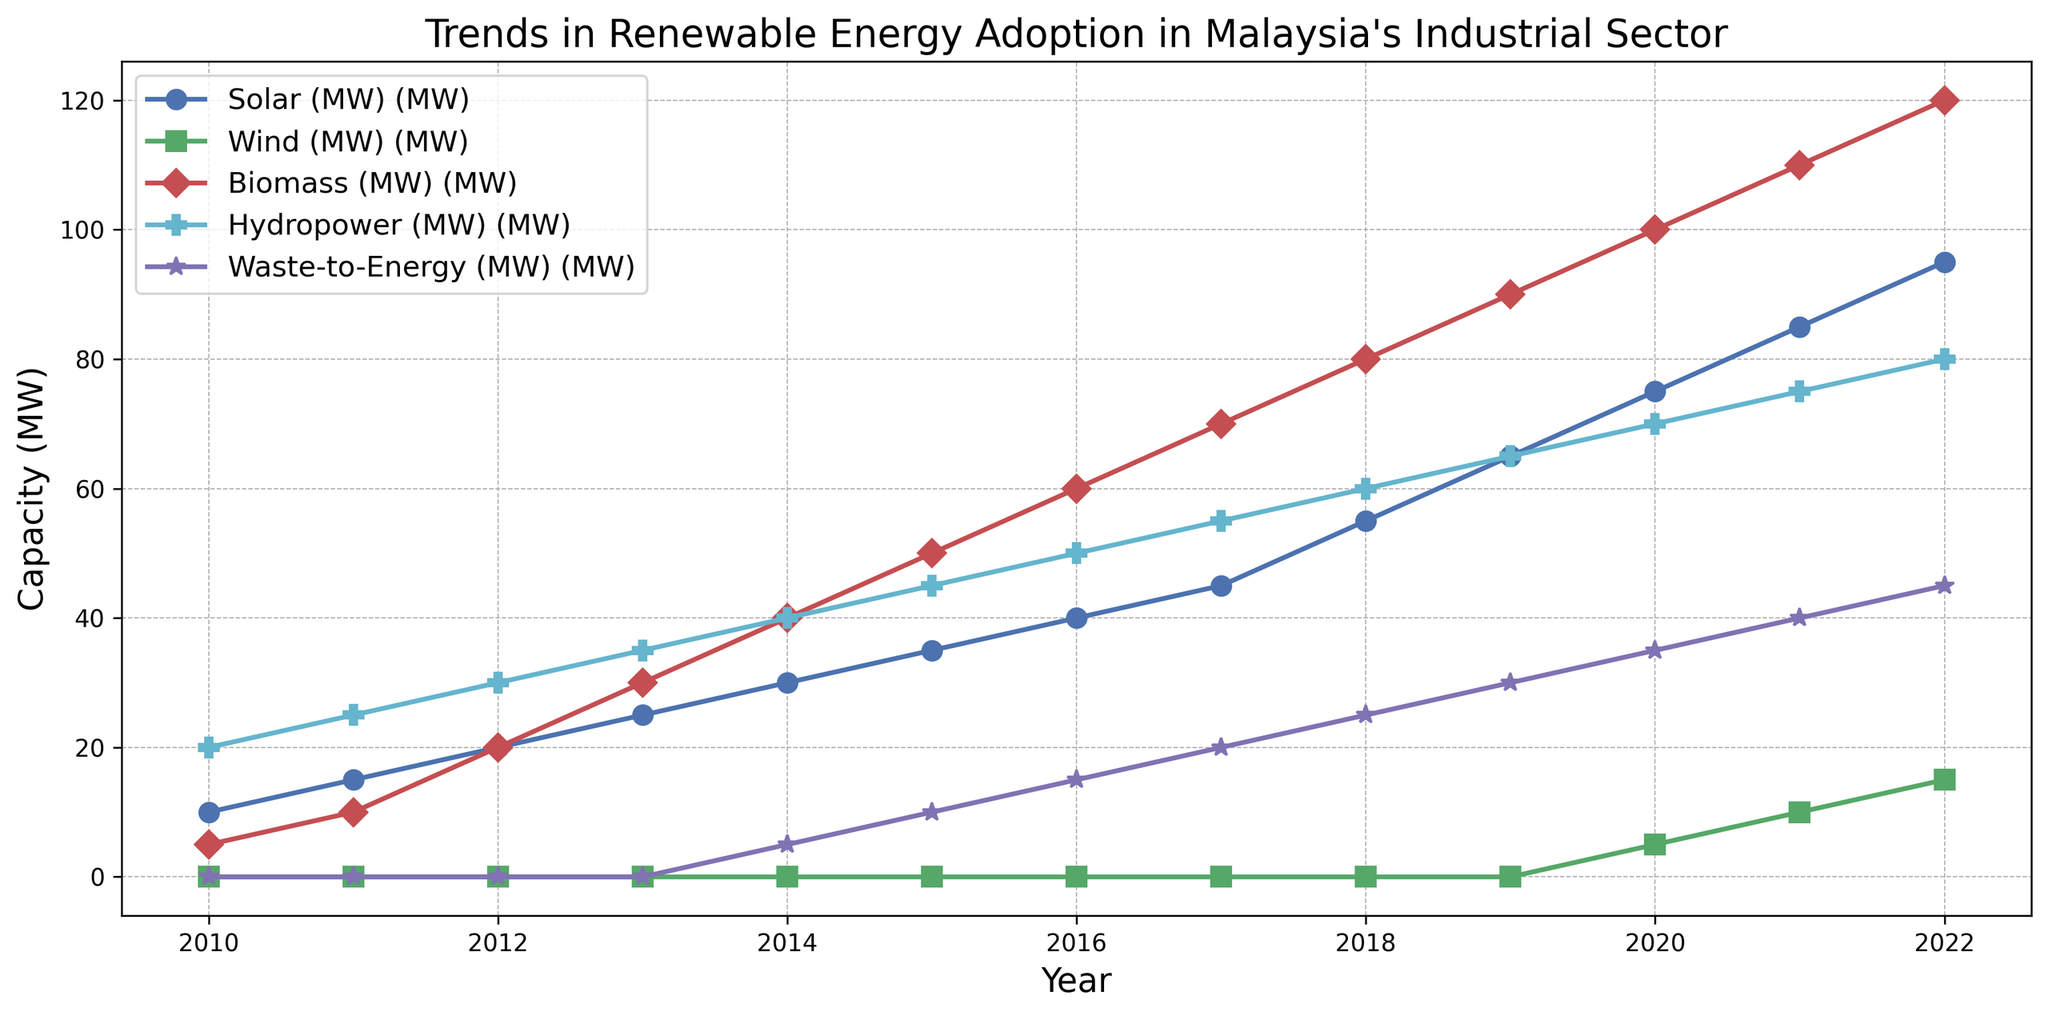What is the trend for Solar energy adoption from 2010 to 2022? To identify the trend, observe the line representing Solar (MW) from 2010 to 2022. It starts at 10 MW in 2010 and increases steadily to 95 MW by 2022.
Answer: Steady increase In which year did Wind energy first appear in the dataset, and what was its capacity? Look for the first non-zero value in the Wind (MW) line. Wind energy first appears in 2020 with a capacity of 5 MW.
Answer: 2020, 5 MW Between Solar and Hydropower, which had a higher capacity in 2015, and by how much? Compare the values of Solar (MW) and Hydropower (MW) in 2015. Solar had 35 MW, and Hydropower had 45 MW. The difference is 45 - 35 = 10 MW.
Answer: Hydropower by 10 MW What is the total capacity of Biomass and Waste-to-Energy in 2014? Sum the capacities of Biomass (MW) and Waste-to-Energy (MW) in 2014. Biomass is 40 MW, and Waste-to-Energy is 5 MW. The total is 40 + 5 = 45 MW.
Answer: 45 MW Which type of renewable energy showed no capacity until 2014? Observe the lines for each type of renewable energy. Wind and Waste-to-Energy both showed no capacity until 2014, but Waste-to-Energy was the later of the two.
Answer: Waste-to-Energy In what year did the combined capacity of Biomass and Solar reach 100 MW? Check the sum of Biomass and Solar capacities for each year to find when it first reaches 100 MW. In 2016, Biomass is 60 MW and Solar is 40 MW, summing to 100 MW.
Answer: 2016 Which energy source had the steepest increase between 2018 and 2019? Determine the difference between 2018 and 2019 for each energy source. Solar increased from 55 MW to 65 MW (10 MW), Biomass from 80 MW to 90 MW (10 MW), Hydropower from 60 MW to 65 MW (5 MW), Waste-to-Energy from 25 MW to 30 MW (5 MW), and Wind remained at 0 MW.
Answer: Solar and Biomass What is the average capacity of Hydropower over the entire period shown? Add up the Hydropower capacities from 2010 to 2022 and divide by the number of years. The sum is 20+25+30+35+40+45+50+55+60+65+70+75+80 = 650 MW over 13 years. 650 / 13 = 50 MW.
Answer: 50 MW How many energy sources reached or exceeded 70 MW capacity by 2022? Check the capacities for each source in 2022. Solar is at 95 MW, Biomass is at 120 MW, Hydropower is at 80 MW, and Waste-to-Energy is at 45 MW. Wind reached 15 MW. Only Solar, Biomass, and Hydropower reached or exceeded 70 MW.
Answer: Three energy sources Was there any year when all the energy types, except Wind, saw an increase in capacity? Look at the year-on-year changes for Solar, Biomass, Hydropower, and Waste-to-Energy. For example, between 2010 and 2011, Solar, Biomass, and Hydropower increased, but Waste-to-Energy did not increase until 2014. Check other years as well. Analyzing in detail, 2015 to 2016 shows increases in Solar, Biomass, Hydropower, and Waste-to-Energy.
Answer: 2015 to 2016 